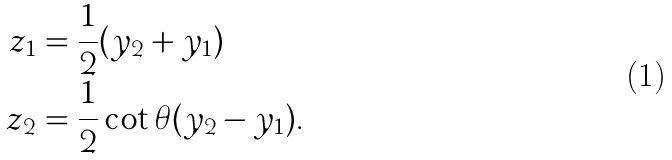Convert formula to latex. <formula><loc_0><loc_0><loc_500><loc_500>z _ { 1 } & = \frac { 1 } { 2 } ( y _ { 2 } + y _ { 1 } ) \\ z _ { 2 } & = \frac { 1 } { 2 } \cot \theta ( y _ { 2 } - y _ { 1 } ) .</formula> 